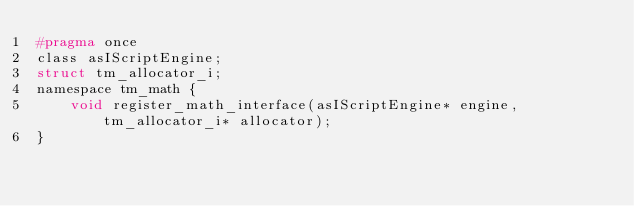<code> <loc_0><loc_0><loc_500><loc_500><_C_>#pragma once
class asIScriptEngine;
struct tm_allocator_i;
namespace tm_math {
	void register_math_interface(asIScriptEngine* engine, tm_allocator_i* allocator);
}</code> 